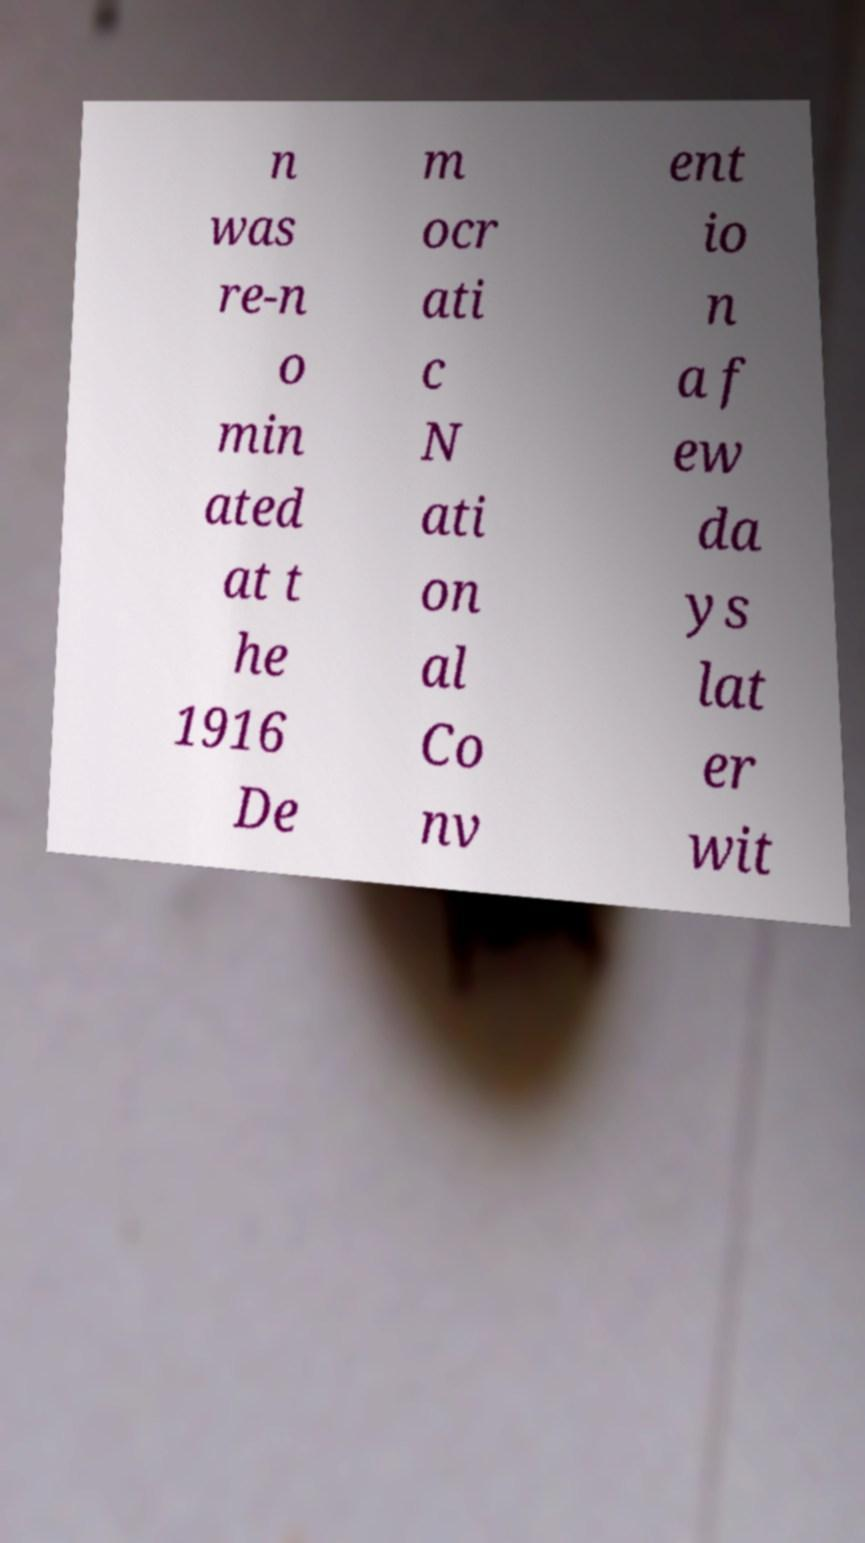Please identify and transcribe the text found in this image. n was re-n o min ated at t he 1916 De m ocr ati c N ati on al Co nv ent io n a f ew da ys lat er wit 